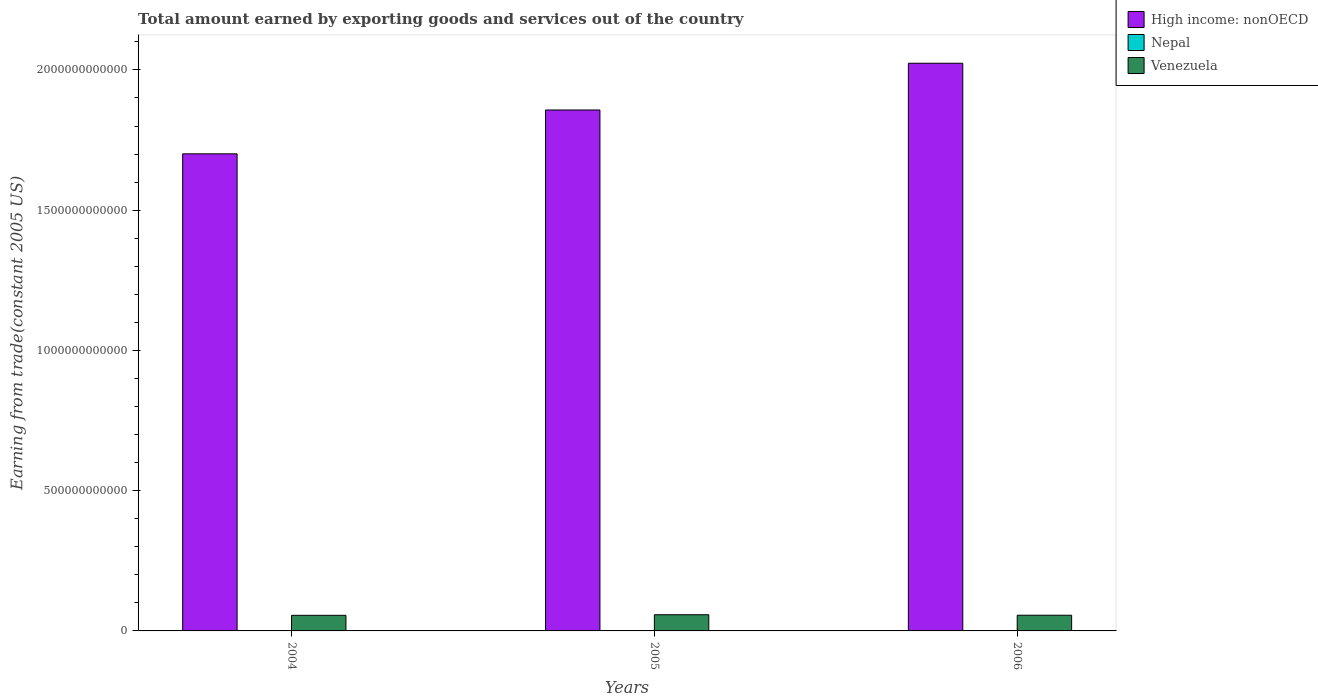How many groups of bars are there?
Make the answer very short. 3. Are the number of bars per tick equal to the number of legend labels?
Give a very brief answer. Yes. Are the number of bars on each tick of the X-axis equal?
Provide a succinct answer. Yes. What is the total amount earned by exporting goods and services in Nepal in 2004?
Your answer should be very brief. 1.22e+09. Across all years, what is the maximum total amount earned by exporting goods and services in Nepal?
Provide a succinct answer. 1.22e+09. Across all years, what is the minimum total amount earned by exporting goods and services in High income: nonOECD?
Provide a short and direct response. 1.70e+12. In which year was the total amount earned by exporting goods and services in Venezuela minimum?
Your response must be concise. 2004. What is the total total amount earned by exporting goods and services in Nepal in the graph?
Your answer should be very brief. 3.58e+09. What is the difference between the total amount earned by exporting goods and services in High income: nonOECD in 2004 and that in 2005?
Your response must be concise. -1.56e+11. What is the difference between the total amount earned by exporting goods and services in Venezuela in 2005 and the total amount earned by exporting goods and services in High income: nonOECD in 2004?
Keep it short and to the point. -1.64e+12. What is the average total amount earned by exporting goods and services in Nepal per year?
Ensure brevity in your answer.  1.19e+09. In the year 2004, what is the difference between the total amount earned by exporting goods and services in High income: nonOECD and total amount earned by exporting goods and services in Venezuela?
Keep it short and to the point. 1.65e+12. In how many years, is the total amount earned by exporting goods and services in Venezuela greater than 900000000000 US$?
Your response must be concise. 0. What is the ratio of the total amount earned by exporting goods and services in Nepal in 2005 to that in 2006?
Your response must be concise. 1.01. Is the total amount earned by exporting goods and services in Venezuela in 2005 less than that in 2006?
Keep it short and to the point. No. Is the difference between the total amount earned by exporting goods and services in High income: nonOECD in 2005 and 2006 greater than the difference between the total amount earned by exporting goods and services in Venezuela in 2005 and 2006?
Your answer should be compact. No. What is the difference between the highest and the second highest total amount earned by exporting goods and services in Nepal?
Give a very brief answer. 3.71e+07. What is the difference between the highest and the lowest total amount earned by exporting goods and services in Nepal?
Ensure brevity in your answer.  5.24e+07. What does the 3rd bar from the left in 2006 represents?
Provide a succinct answer. Venezuela. What does the 3rd bar from the right in 2006 represents?
Offer a very short reply. High income: nonOECD. How many years are there in the graph?
Give a very brief answer. 3. What is the difference between two consecutive major ticks on the Y-axis?
Make the answer very short. 5.00e+11. Does the graph contain any zero values?
Give a very brief answer. No. Does the graph contain grids?
Your answer should be compact. No. How many legend labels are there?
Ensure brevity in your answer.  3. What is the title of the graph?
Your response must be concise. Total amount earned by exporting goods and services out of the country. What is the label or title of the Y-axis?
Your answer should be very brief. Earning from trade(constant 2005 US). What is the Earning from trade(constant 2005 US) in High income: nonOECD in 2004?
Ensure brevity in your answer.  1.70e+12. What is the Earning from trade(constant 2005 US) in Nepal in 2004?
Offer a terse response. 1.22e+09. What is the Earning from trade(constant 2005 US) of Venezuela in 2004?
Your answer should be compact. 5.56e+1. What is the Earning from trade(constant 2005 US) in High income: nonOECD in 2005?
Your response must be concise. 1.86e+12. What is the Earning from trade(constant 2005 US) of Nepal in 2005?
Offer a very short reply. 1.19e+09. What is the Earning from trade(constant 2005 US) in Venezuela in 2005?
Your answer should be very brief. 5.77e+1. What is the Earning from trade(constant 2005 US) in High income: nonOECD in 2006?
Your answer should be compact. 2.02e+12. What is the Earning from trade(constant 2005 US) in Nepal in 2006?
Offer a very short reply. 1.17e+09. What is the Earning from trade(constant 2005 US) of Venezuela in 2006?
Offer a very short reply. 5.60e+1. Across all years, what is the maximum Earning from trade(constant 2005 US) of High income: nonOECD?
Offer a terse response. 2.02e+12. Across all years, what is the maximum Earning from trade(constant 2005 US) of Nepal?
Give a very brief answer. 1.22e+09. Across all years, what is the maximum Earning from trade(constant 2005 US) of Venezuela?
Provide a succinct answer. 5.77e+1. Across all years, what is the minimum Earning from trade(constant 2005 US) in High income: nonOECD?
Give a very brief answer. 1.70e+12. Across all years, what is the minimum Earning from trade(constant 2005 US) of Nepal?
Keep it short and to the point. 1.17e+09. Across all years, what is the minimum Earning from trade(constant 2005 US) in Venezuela?
Offer a very short reply. 5.56e+1. What is the total Earning from trade(constant 2005 US) in High income: nonOECD in the graph?
Offer a very short reply. 5.58e+12. What is the total Earning from trade(constant 2005 US) in Nepal in the graph?
Provide a short and direct response. 3.58e+09. What is the total Earning from trade(constant 2005 US) in Venezuela in the graph?
Provide a short and direct response. 1.69e+11. What is the difference between the Earning from trade(constant 2005 US) in High income: nonOECD in 2004 and that in 2005?
Make the answer very short. -1.56e+11. What is the difference between the Earning from trade(constant 2005 US) in Nepal in 2004 and that in 2005?
Your response must be concise. 3.71e+07. What is the difference between the Earning from trade(constant 2005 US) of Venezuela in 2004 and that in 2005?
Your response must be concise. -2.10e+09. What is the difference between the Earning from trade(constant 2005 US) of High income: nonOECD in 2004 and that in 2006?
Provide a short and direct response. -3.23e+11. What is the difference between the Earning from trade(constant 2005 US) in Nepal in 2004 and that in 2006?
Your answer should be very brief. 5.24e+07. What is the difference between the Earning from trade(constant 2005 US) in Venezuela in 2004 and that in 2006?
Offer a terse response. -3.55e+08. What is the difference between the Earning from trade(constant 2005 US) of High income: nonOECD in 2005 and that in 2006?
Offer a terse response. -1.67e+11. What is the difference between the Earning from trade(constant 2005 US) in Nepal in 2005 and that in 2006?
Give a very brief answer. 1.53e+07. What is the difference between the Earning from trade(constant 2005 US) in Venezuela in 2005 and that in 2006?
Your answer should be compact. 1.74e+09. What is the difference between the Earning from trade(constant 2005 US) of High income: nonOECD in 2004 and the Earning from trade(constant 2005 US) of Nepal in 2005?
Ensure brevity in your answer.  1.70e+12. What is the difference between the Earning from trade(constant 2005 US) in High income: nonOECD in 2004 and the Earning from trade(constant 2005 US) in Venezuela in 2005?
Offer a very short reply. 1.64e+12. What is the difference between the Earning from trade(constant 2005 US) in Nepal in 2004 and the Earning from trade(constant 2005 US) in Venezuela in 2005?
Keep it short and to the point. -5.65e+1. What is the difference between the Earning from trade(constant 2005 US) in High income: nonOECD in 2004 and the Earning from trade(constant 2005 US) in Nepal in 2006?
Your answer should be compact. 1.70e+12. What is the difference between the Earning from trade(constant 2005 US) of High income: nonOECD in 2004 and the Earning from trade(constant 2005 US) of Venezuela in 2006?
Provide a short and direct response. 1.64e+12. What is the difference between the Earning from trade(constant 2005 US) of Nepal in 2004 and the Earning from trade(constant 2005 US) of Venezuela in 2006?
Your answer should be very brief. -5.47e+1. What is the difference between the Earning from trade(constant 2005 US) of High income: nonOECD in 2005 and the Earning from trade(constant 2005 US) of Nepal in 2006?
Ensure brevity in your answer.  1.86e+12. What is the difference between the Earning from trade(constant 2005 US) in High income: nonOECD in 2005 and the Earning from trade(constant 2005 US) in Venezuela in 2006?
Offer a terse response. 1.80e+12. What is the difference between the Earning from trade(constant 2005 US) in Nepal in 2005 and the Earning from trade(constant 2005 US) in Venezuela in 2006?
Keep it short and to the point. -5.48e+1. What is the average Earning from trade(constant 2005 US) in High income: nonOECD per year?
Your response must be concise. 1.86e+12. What is the average Earning from trade(constant 2005 US) of Nepal per year?
Keep it short and to the point. 1.19e+09. What is the average Earning from trade(constant 2005 US) of Venezuela per year?
Give a very brief answer. 5.64e+1. In the year 2004, what is the difference between the Earning from trade(constant 2005 US) of High income: nonOECD and Earning from trade(constant 2005 US) of Nepal?
Make the answer very short. 1.70e+12. In the year 2004, what is the difference between the Earning from trade(constant 2005 US) of High income: nonOECD and Earning from trade(constant 2005 US) of Venezuela?
Provide a short and direct response. 1.65e+12. In the year 2004, what is the difference between the Earning from trade(constant 2005 US) in Nepal and Earning from trade(constant 2005 US) in Venezuela?
Your answer should be compact. -5.44e+1. In the year 2005, what is the difference between the Earning from trade(constant 2005 US) in High income: nonOECD and Earning from trade(constant 2005 US) in Nepal?
Your answer should be compact. 1.86e+12. In the year 2005, what is the difference between the Earning from trade(constant 2005 US) in High income: nonOECD and Earning from trade(constant 2005 US) in Venezuela?
Provide a succinct answer. 1.80e+12. In the year 2005, what is the difference between the Earning from trade(constant 2005 US) of Nepal and Earning from trade(constant 2005 US) of Venezuela?
Offer a terse response. -5.65e+1. In the year 2006, what is the difference between the Earning from trade(constant 2005 US) in High income: nonOECD and Earning from trade(constant 2005 US) in Nepal?
Your response must be concise. 2.02e+12. In the year 2006, what is the difference between the Earning from trade(constant 2005 US) of High income: nonOECD and Earning from trade(constant 2005 US) of Venezuela?
Your response must be concise. 1.97e+12. In the year 2006, what is the difference between the Earning from trade(constant 2005 US) in Nepal and Earning from trade(constant 2005 US) in Venezuela?
Give a very brief answer. -5.48e+1. What is the ratio of the Earning from trade(constant 2005 US) of High income: nonOECD in 2004 to that in 2005?
Ensure brevity in your answer.  0.92. What is the ratio of the Earning from trade(constant 2005 US) of Nepal in 2004 to that in 2005?
Provide a short and direct response. 1.03. What is the ratio of the Earning from trade(constant 2005 US) of Venezuela in 2004 to that in 2005?
Make the answer very short. 0.96. What is the ratio of the Earning from trade(constant 2005 US) in High income: nonOECD in 2004 to that in 2006?
Keep it short and to the point. 0.84. What is the ratio of the Earning from trade(constant 2005 US) in Nepal in 2004 to that in 2006?
Your answer should be very brief. 1.04. What is the ratio of the Earning from trade(constant 2005 US) in High income: nonOECD in 2005 to that in 2006?
Offer a terse response. 0.92. What is the ratio of the Earning from trade(constant 2005 US) of Nepal in 2005 to that in 2006?
Give a very brief answer. 1.01. What is the ratio of the Earning from trade(constant 2005 US) in Venezuela in 2005 to that in 2006?
Ensure brevity in your answer.  1.03. What is the difference between the highest and the second highest Earning from trade(constant 2005 US) of High income: nonOECD?
Keep it short and to the point. 1.67e+11. What is the difference between the highest and the second highest Earning from trade(constant 2005 US) in Nepal?
Your answer should be compact. 3.71e+07. What is the difference between the highest and the second highest Earning from trade(constant 2005 US) in Venezuela?
Your response must be concise. 1.74e+09. What is the difference between the highest and the lowest Earning from trade(constant 2005 US) in High income: nonOECD?
Give a very brief answer. 3.23e+11. What is the difference between the highest and the lowest Earning from trade(constant 2005 US) in Nepal?
Ensure brevity in your answer.  5.24e+07. What is the difference between the highest and the lowest Earning from trade(constant 2005 US) of Venezuela?
Give a very brief answer. 2.10e+09. 